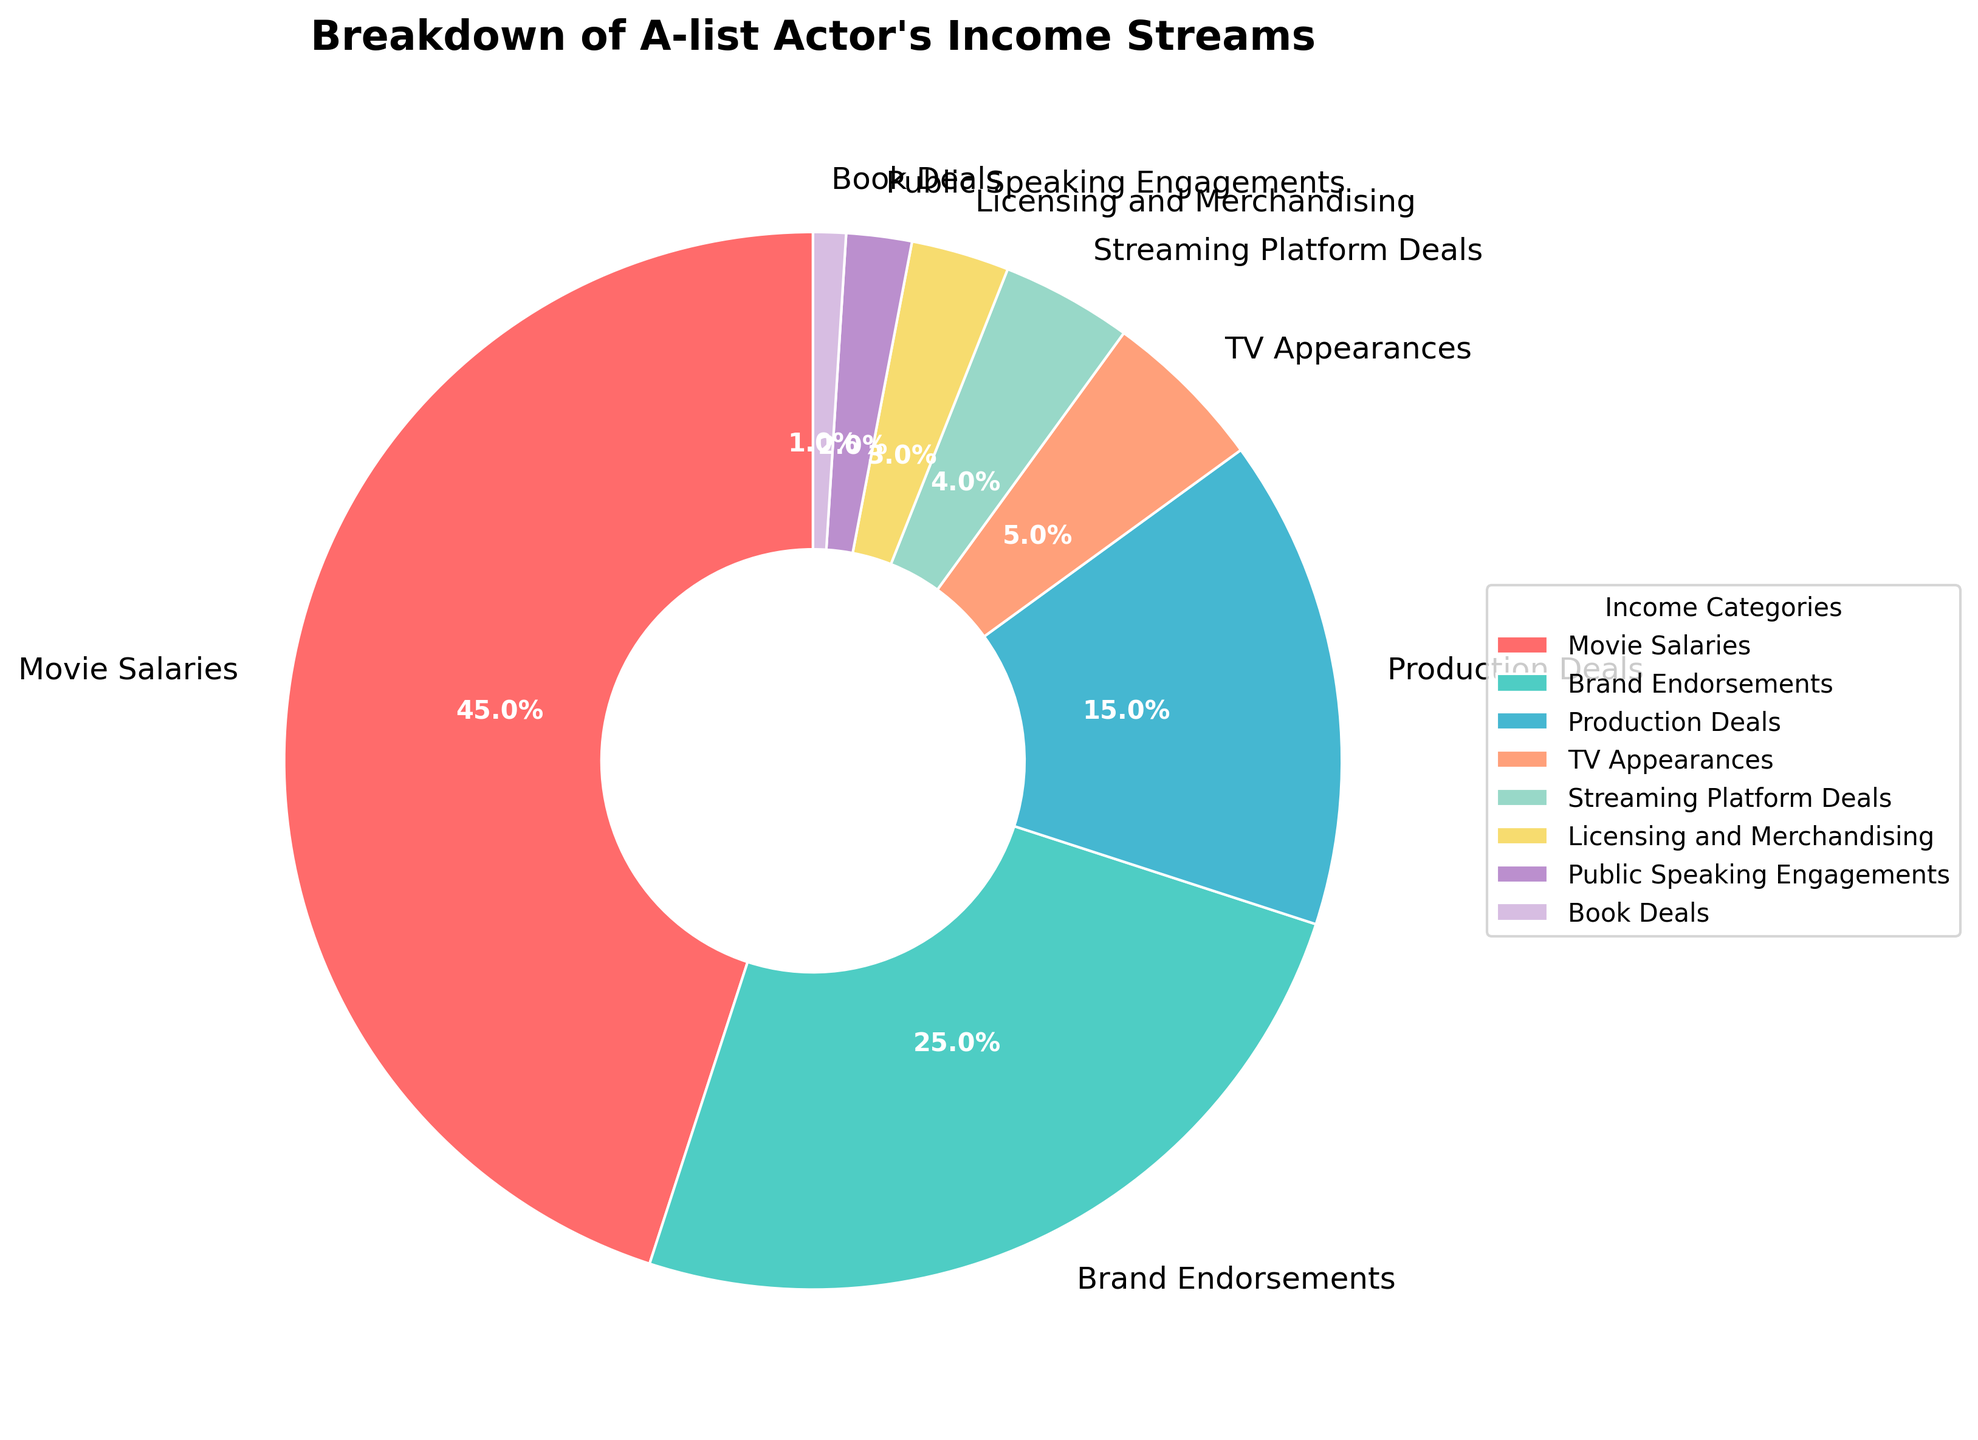What percentage of the actor's income comes from Movie Salaries and Brand Endorsements combined? The percentage from Movie Salaries is 45%, and from Brand Endorsements is 25%. Adding these together, 45% + 25% = 70%.
Answer: 70% What is the smallest income stream for the actor? By examining the pie chart, the segment for Book Deals is the smallest, contributing 1% to the actor's income.
Answer: Book Deals How much more does the actor earn from Movie Salaries compared to Production Deals? The percentage for Movie Salaries is 45%, and for Production Deals, it is 15%. Calculating the difference, 45% - 15% = 30%.
Answer: 30% Which income streams combined make up less than 10% of the actor's total income? The segments for TV Appearances (5%), Streaming Platform Deals (4%), Licensing and Merchandising (3%), Public Speaking Engagements (2%), and Book Deals (1%) each contribute a small portion. Adding their percentages: 5% + 4% + 3% + 2% + 1% = 15%. Individually, all income streams apart from TV Appearances make up less than 10%.
Answer: Streaming Platform Deals, Licensing and Merchandising, Public Speaking Engagements, Book Deals Between which two categories is the income percentage difference the smallest? Assessing the segments, the smallest difference is between Streaming Platform Deals (4%) and Licensing and Merchandising (3%), making the difference 4% - 3% = 1%.
Answer: Streaming Platform Deals and Licensing and Merchandising Which category contributes more to the actor's income: Production Deals or TV Appearances? The pie chart shows that Production Deals account for 15%, while TV Appearances contribute 5%. Thus, Production Deals contribute more.
Answer: Production Deals What is the total percentage of income from categories other than Movie Salaries and Brand Endorsements? Excluding the segments for Movie Salaries (45%) and Brand Endorsements (25%), the percentages for the other categories are: Production Deals (15%), TV Appearances (5%), Streaming Platform Deals (4%), Licensing and Merchandising (3%), Public Speaking Engagements (2%), and Book Deals (1%). Summing these categories gives 15% + 5% + 4% + 3% + 2% + 1% = 30%.
Answer: 30% What color represents the Production Deals segment? Noting the color scheme in the pie chart, the Production Deals section is represented in the dark blue color wedge.
Answer: dark blue 